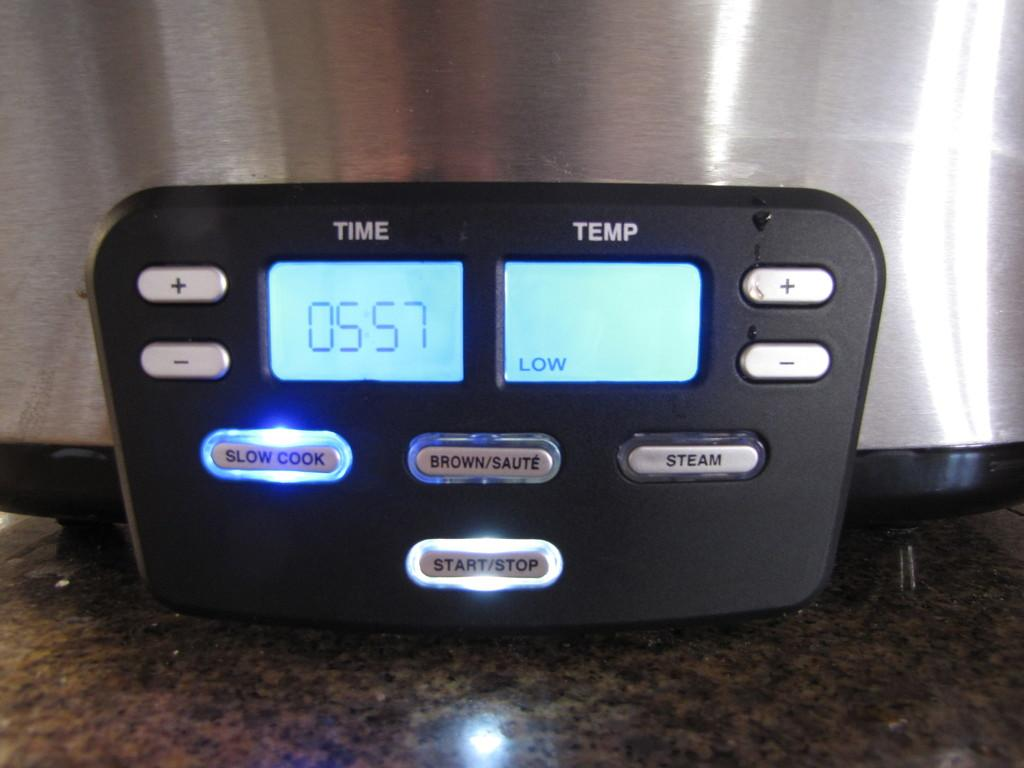<image>
Write a terse but informative summary of the picture. Alarm device showing Time and Temperature, Slow Cook. Brown Saute, Steam, and Start/Stop. 